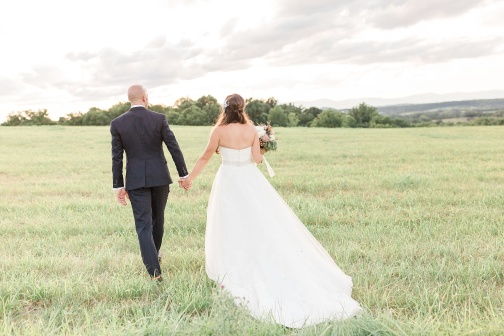Describe the emotions you perceive from this image. The image conveys a sense of serenity and joy. The couple, holding hands and walking through the verdant field, appear intimate and connected. Their relaxed posture and the tranquil setting symbolize happiness, love, and a hopeful future together. 